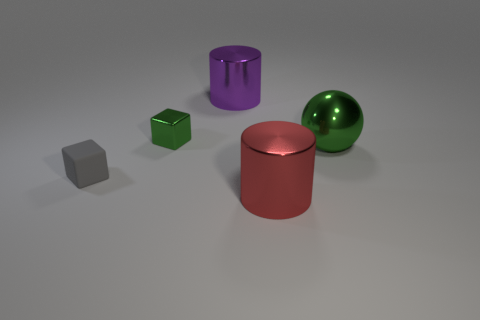Is the number of cubes less than the number of large green objects?
Provide a short and direct response. No. There is a thing that is on the left side of the large purple thing and behind the gray rubber block; how big is it?
Offer a terse response. Small. Is the gray object the same size as the purple metal cylinder?
Provide a short and direct response. No. Does the shiny cylinder that is behind the small green metal block have the same color as the tiny shiny object?
Provide a short and direct response. No. There is a big green thing; how many tiny rubber blocks are on the left side of it?
Your answer should be very brief. 1. Are there more big red metal cylinders than metal cylinders?
Your response must be concise. No. There is a large metal object that is both behind the red metal cylinder and in front of the large purple metal object; what is its shape?
Keep it short and to the point. Sphere. Are any big metal cylinders visible?
Offer a terse response. Yes. There is a big red object that is the same shape as the big purple object; what material is it?
Provide a succinct answer. Metal. There is a green thing that is right of the big shiny thing on the left side of the big cylinder that is right of the large purple cylinder; what shape is it?
Your answer should be very brief. Sphere. 